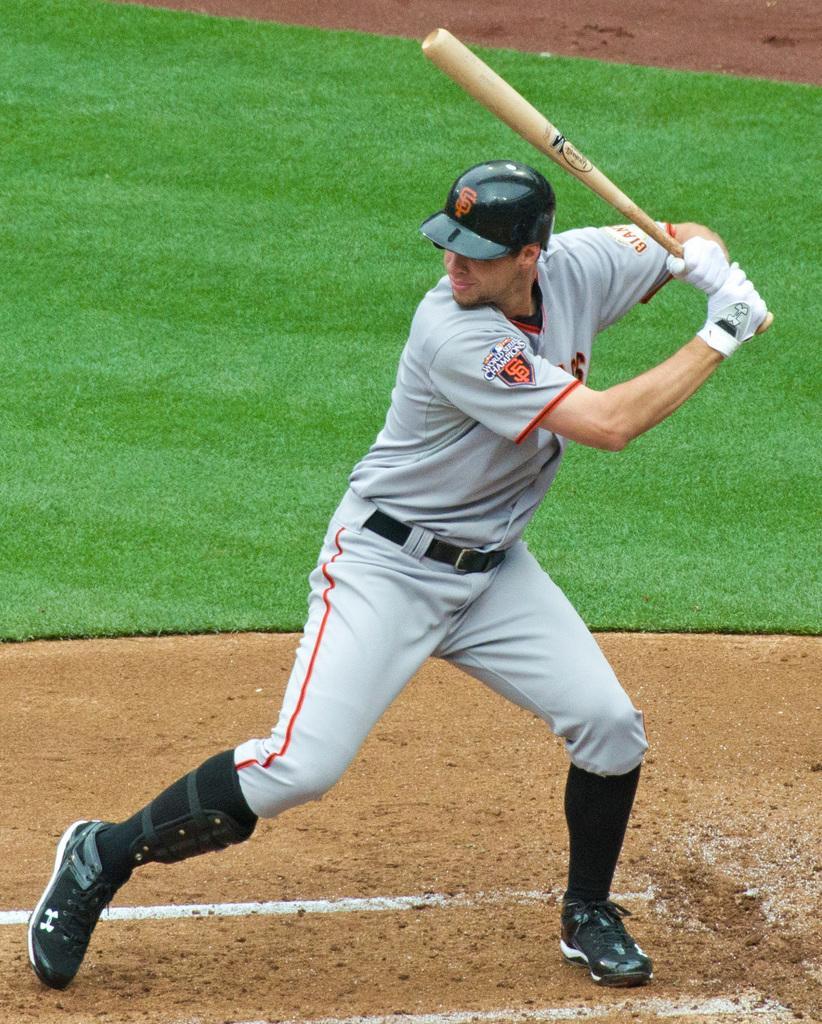Can you describe this image briefly? Here we can see a man holding a bat with his hands and this is ground. 